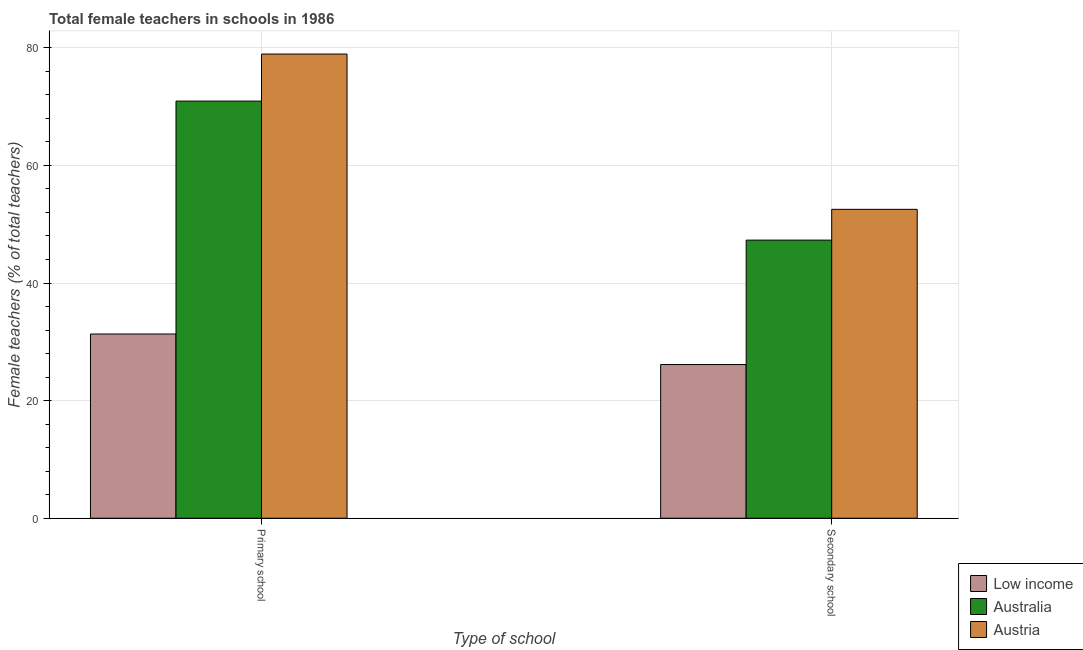How many bars are there on the 2nd tick from the left?
Keep it short and to the point. 3. How many bars are there on the 1st tick from the right?
Make the answer very short. 3. What is the label of the 2nd group of bars from the left?
Provide a short and direct response. Secondary school. What is the percentage of female teachers in primary schools in Low income?
Ensure brevity in your answer.  31.33. Across all countries, what is the maximum percentage of female teachers in primary schools?
Your response must be concise. 78.95. Across all countries, what is the minimum percentage of female teachers in primary schools?
Keep it short and to the point. 31.33. In which country was the percentage of female teachers in primary schools maximum?
Your response must be concise. Austria. In which country was the percentage of female teachers in primary schools minimum?
Make the answer very short. Low income. What is the total percentage of female teachers in secondary schools in the graph?
Offer a terse response. 125.97. What is the difference between the percentage of female teachers in primary schools in Australia and that in Low income?
Your answer should be very brief. 39.61. What is the difference between the percentage of female teachers in primary schools in Australia and the percentage of female teachers in secondary schools in Low income?
Your answer should be compact. 44.8. What is the average percentage of female teachers in primary schools per country?
Make the answer very short. 60.41. What is the difference between the percentage of female teachers in secondary schools and percentage of female teachers in primary schools in Australia?
Ensure brevity in your answer.  -23.64. What is the ratio of the percentage of female teachers in secondary schools in Low income to that in Austria?
Provide a succinct answer. 0.5. Is the percentage of female teachers in primary schools in Austria less than that in Australia?
Your answer should be compact. No. What does the 1st bar from the left in Primary school represents?
Your response must be concise. Low income. Are all the bars in the graph horizontal?
Offer a terse response. No. How many countries are there in the graph?
Provide a succinct answer. 3. Are the values on the major ticks of Y-axis written in scientific E-notation?
Offer a very short reply. No. Does the graph contain any zero values?
Offer a very short reply. No. Does the graph contain grids?
Make the answer very short. Yes. Where does the legend appear in the graph?
Make the answer very short. Bottom right. How many legend labels are there?
Your response must be concise. 3. How are the legend labels stacked?
Offer a terse response. Vertical. What is the title of the graph?
Your answer should be compact. Total female teachers in schools in 1986. What is the label or title of the X-axis?
Your response must be concise. Type of school. What is the label or title of the Y-axis?
Offer a terse response. Female teachers (% of total teachers). What is the Female teachers (% of total teachers) in Low income in Primary school?
Provide a succinct answer. 31.33. What is the Female teachers (% of total teachers) of Australia in Primary school?
Your answer should be compact. 70.94. What is the Female teachers (% of total teachers) of Austria in Primary school?
Provide a succinct answer. 78.95. What is the Female teachers (% of total teachers) of Low income in Secondary school?
Ensure brevity in your answer.  26.14. What is the Female teachers (% of total teachers) in Australia in Secondary school?
Ensure brevity in your answer.  47.3. What is the Female teachers (% of total teachers) of Austria in Secondary school?
Provide a short and direct response. 52.53. Across all Type of school, what is the maximum Female teachers (% of total teachers) in Low income?
Give a very brief answer. 31.33. Across all Type of school, what is the maximum Female teachers (% of total teachers) of Australia?
Offer a terse response. 70.94. Across all Type of school, what is the maximum Female teachers (% of total teachers) in Austria?
Provide a short and direct response. 78.95. Across all Type of school, what is the minimum Female teachers (% of total teachers) of Low income?
Ensure brevity in your answer.  26.14. Across all Type of school, what is the minimum Female teachers (% of total teachers) in Australia?
Offer a very short reply. 47.3. Across all Type of school, what is the minimum Female teachers (% of total teachers) of Austria?
Offer a terse response. 52.53. What is the total Female teachers (% of total teachers) in Low income in the graph?
Make the answer very short. 57.47. What is the total Female teachers (% of total teachers) of Australia in the graph?
Your answer should be very brief. 118.24. What is the total Female teachers (% of total teachers) of Austria in the graph?
Provide a short and direct response. 131.48. What is the difference between the Female teachers (% of total teachers) in Low income in Primary school and that in Secondary school?
Your response must be concise. 5.19. What is the difference between the Female teachers (% of total teachers) of Australia in Primary school and that in Secondary school?
Your answer should be very brief. 23.64. What is the difference between the Female teachers (% of total teachers) in Austria in Primary school and that in Secondary school?
Keep it short and to the point. 26.41. What is the difference between the Female teachers (% of total teachers) of Low income in Primary school and the Female teachers (% of total teachers) of Australia in Secondary school?
Your answer should be very brief. -15.97. What is the difference between the Female teachers (% of total teachers) of Low income in Primary school and the Female teachers (% of total teachers) of Austria in Secondary school?
Provide a short and direct response. -21.2. What is the difference between the Female teachers (% of total teachers) in Australia in Primary school and the Female teachers (% of total teachers) in Austria in Secondary school?
Provide a short and direct response. 18.41. What is the average Female teachers (% of total teachers) of Low income per Type of school?
Provide a succinct answer. 28.73. What is the average Female teachers (% of total teachers) of Australia per Type of school?
Your response must be concise. 59.12. What is the average Female teachers (% of total teachers) in Austria per Type of school?
Your answer should be compact. 65.74. What is the difference between the Female teachers (% of total teachers) of Low income and Female teachers (% of total teachers) of Australia in Primary school?
Keep it short and to the point. -39.61. What is the difference between the Female teachers (% of total teachers) of Low income and Female teachers (% of total teachers) of Austria in Primary school?
Keep it short and to the point. -47.62. What is the difference between the Female teachers (% of total teachers) of Australia and Female teachers (% of total teachers) of Austria in Primary school?
Provide a short and direct response. -8. What is the difference between the Female teachers (% of total teachers) of Low income and Female teachers (% of total teachers) of Australia in Secondary school?
Keep it short and to the point. -21.16. What is the difference between the Female teachers (% of total teachers) of Low income and Female teachers (% of total teachers) of Austria in Secondary school?
Your response must be concise. -26.4. What is the difference between the Female teachers (% of total teachers) of Australia and Female teachers (% of total teachers) of Austria in Secondary school?
Provide a short and direct response. -5.24. What is the ratio of the Female teachers (% of total teachers) in Low income in Primary school to that in Secondary school?
Offer a very short reply. 1.2. What is the ratio of the Female teachers (% of total teachers) of Australia in Primary school to that in Secondary school?
Offer a terse response. 1.5. What is the ratio of the Female teachers (% of total teachers) in Austria in Primary school to that in Secondary school?
Provide a succinct answer. 1.5. What is the difference between the highest and the second highest Female teachers (% of total teachers) of Low income?
Provide a short and direct response. 5.19. What is the difference between the highest and the second highest Female teachers (% of total teachers) in Australia?
Offer a terse response. 23.64. What is the difference between the highest and the second highest Female teachers (% of total teachers) in Austria?
Your response must be concise. 26.41. What is the difference between the highest and the lowest Female teachers (% of total teachers) of Low income?
Provide a succinct answer. 5.19. What is the difference between the highest and the lowest Female teachers (% of total teachers) of Australia?
Your answer should be compact. 23.64. What is the difference between the highest and the lowest Female teachers (% of total teachers) of Austria?
Provide a succinct answer. 26.41. 